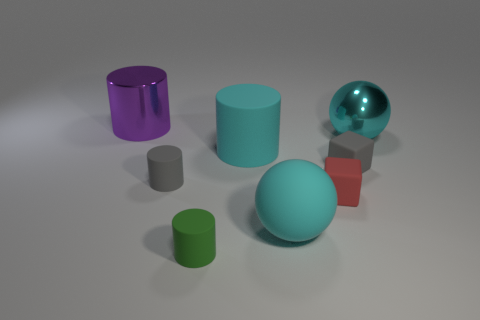Add 1 red matte cubes. How many objects exist? 9 Subtract all balls. How many objects are left? 6 Add 4 purple shiny cylinders. How many purple shiny cylinders exist? 5 Subtract 0 brown cylinders. How many objects are left? 8 Subtract all cyan rubber objects. Subtract all large purple cylinders. How many objects are left? 5 Add 3 cyan metallic things. How many cyan metallic things are left? 4 